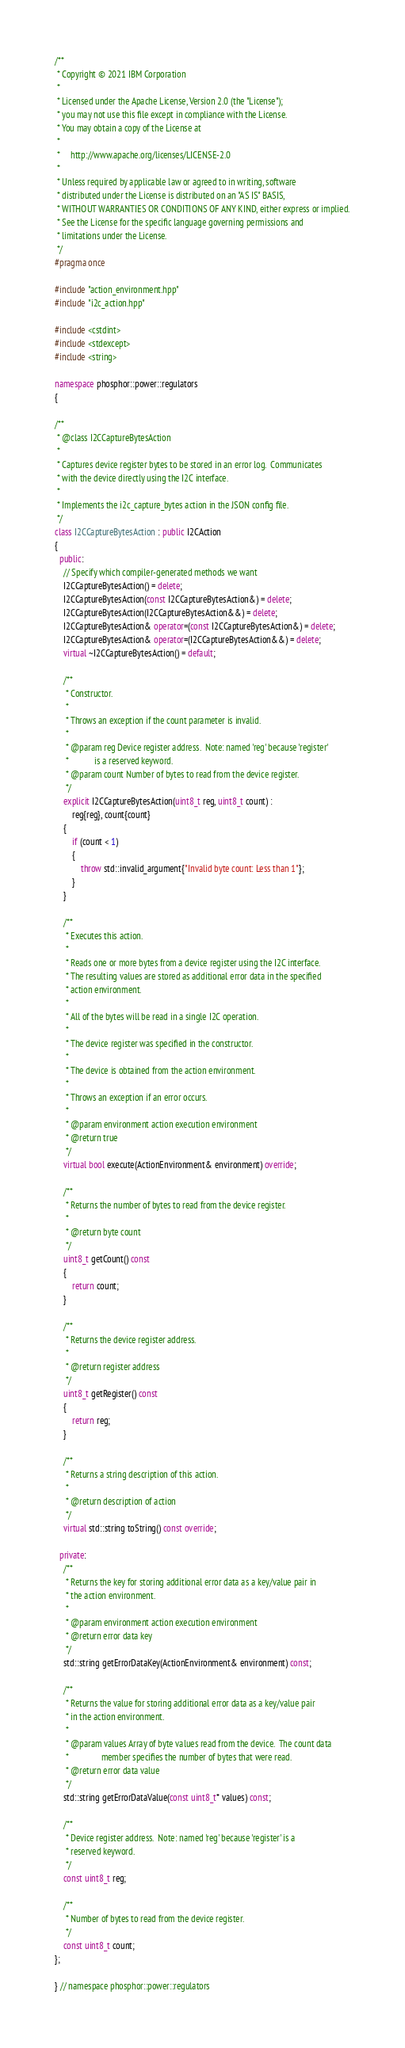<code> <loc_0><loc_0><loc_500><loc_500><_C++_>/**
 * Copyright © 2021 IBM Corporation
 *
 * Licensed under the Apache License, Version 2.0 (the "License");
 * you may not use this file except in compliance with the License.
 * You may obtain a copy of the License at
 *
 *     http://www.apache.org/licenses/LICENSE-2.0
 *
 * Unless required by applicable law or agreed to in writing, software
 * distributed under the License is distributed on an "AS IS" BASIS,
 * WITHOUT WARRANTIES OR CONDITIONS OF ANY KIND, either express or implied.
 * See the License for the specific language governing permissions and
 * limitations under the License.
 */
#pragma once

#include "action_environment.hpp"
#include "i2c_action.hpp"

#include <cstdint>
#include <stdexcept>
#include <string>

namespace phosphor::power::regulators
{

/**
 * @class I2CCaptureBytesAction
 *
 * Captures device register bytes to be stored in an error log.  Communicates
 * with the device directly using the I2C interface.
 *
 * Implements the i2c_capture_bytes action in the JSON config file.
 */
class I2CCaptureBytesAction : public I2CAction
{
  public:
    // Specify which compiler-generated methods we want
    I2CCaptureBytesAction() = delete;
    I2CCaptureBytesAction(const I2CCaptureBytesAction&) = delete;
    I2CCaptureBytesAction(I2CCaptureBytesAction&&) = delete;
    I2CCaptureBytesAction& operator=(const I2CCaptureBytesAction&) = delete;
    I2CCaptureBytesAction& operator=(I2CCaptureBytesAction&&) = delete;
    virtual ~I2CCaptureBytesAction() = default;

    /**
     * Constructor.
     *
     * Throws an exception if the count parameter is invalid.
     *
     * @param reg Device register address.  Note: named 'reg' because 'register'
     *            is a reserved keyword.
     * @param count Number of bytes to read from the device register.
     */
    explicit I2CCaptureBytesAction(uint8_t reg, uint8_t count) :
        reg{reg}, count{count}
    {
        if (count < 1)
        {
            throw std::invalid_argument{"Invalid byte count: Less than 1"};
        }
    }

    /**
     * Executes this action.
     *
     * Reads one or more bytes from a device register using the I2C interface.
     * The resulting values are stored as additional error data in the specified
     * action environment.
     *
     * All of the bytes will be read in a single I2C operation.
     *
     * The device register was specified in the constructor.
     *
     * The device is obtained from the action environment.
     *
     * Throws an exception if an error occurs.
     *
     * @param environment action execution environment
     * @return true
     */
    virtual bool execute(ActionEnvironment& environment) override;

    /**
     * Returns the number of bytes to read from the device register.
     *
     * @return byte count
     */
    uint8_t getCount() const
    {
        return count;
    }

    /**
     * Returns the device register address.
     *
     * @return register address
     */
    uint8_t getRegister() const
    {
        return reg;
    }

    /**
     * Returns a string description of this action.
     *
     * @return description of action
     */
    virtual std::string toString() const override;

  private:
    /**
     * Returns the key for storing additional error data as a key/value pair in
     * the action environment.
     *
     * @param environment action execution environment
     * @return error data key
     */
    std::string getErrorDataKey(ActionEnvironment& environment) const;

    /**
     * Returns the value for storing additional error data as a key/value pair
     * in the action environment.
     *
     * @param values Array of byte values read from the device.  The count data
     *               member specifies the number of bytes that were read.
     * @return error data value
     */
    std::string getErrorDataValue(const uint8_t* values) const;

    /**
     * Device register address.  Note: named 'reg' because 'register' is a
     * reserved keyword.
     */
    const uint8_t reg;

    /**
     * Number of bytes to read from the device register.
     */
    const uint8_t count;
};

} // namespace phosphor::power::regulators
</code> 